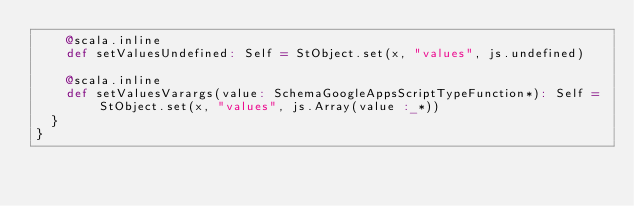<code> <loc_0><loc_0><loc_500><loc_500><_Scala_>    @scala.inline
    def setValuesUndefined: Self = StObject.set(x, "values", js.undefined)
    
    @scala.inline
    def setValuesVarargs(value: SchemaGoogleAppsScriptTypeFunction*): Self = StObject.set(x, "values", js.Array(value :_*))
  }
}
</code> 